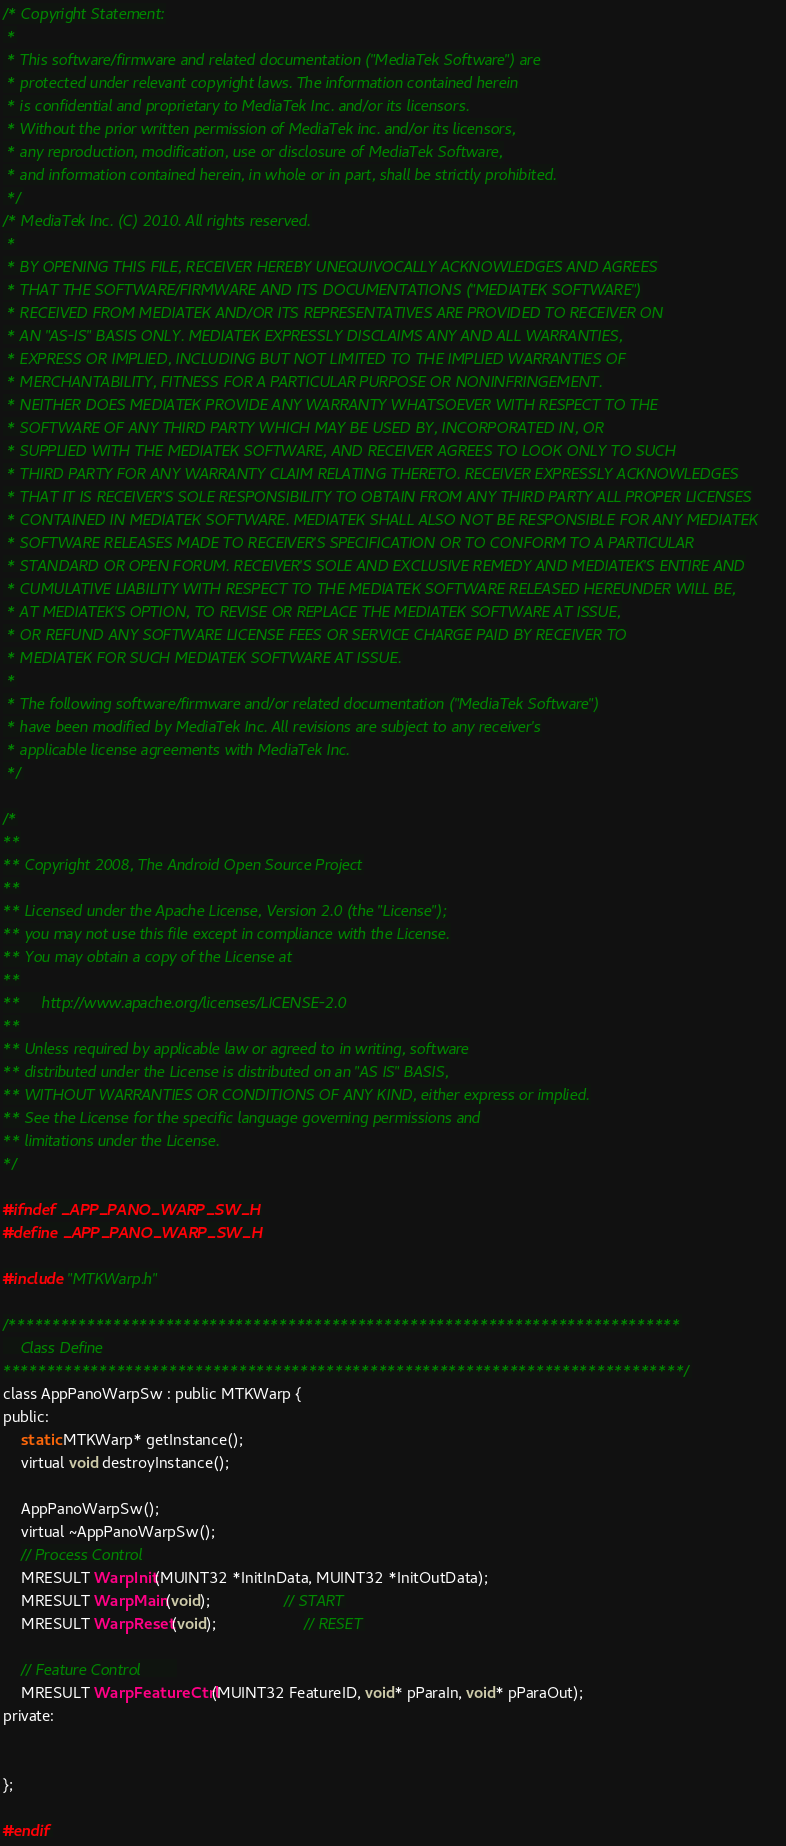Convert code to text. <code><loc_0><loc_0><loc_500><loc_500><_C_>/* Copyright Statement:
 *
 * This software/firmware and related documentation ("MediaTek Software") are
 * protected under relevant copyright laws. The information contained herein
 * is confidential and proprietary to MediaTek Inc. and/or its licensors.
 * Without the prior written permission of MediaTek inc. and/or its licensors,
 * any reproduction, modification, use or disclosure of MediaTek Software,
 * and information contained herein, in whole or in part, shall be strictly prohibited.
 */
/* MediaTek Inc. (C) 2010. All rights reserved.
 *
 * BY OPENING THIS FILE, RECEIVER HEREBY UNEQUIVOCALLY ACKNOWLEDGES AND AGREES
 * THAT THE SOFTWARE/FIRMWARE AND ITS DOCUMENTATIONS ("MEDIATEK SOFTWARE")
 * RECEIVED FROM MEDIATEK AND/OR ITS REPRESENTATIVES ARE PROVIDED TO RECEIVER ON
 * AN "AS-IS" BASIS ONLY. MEDIATEK EXPRESSLY DISCLAIMS ANY AND ALL WARRANTIES,
 * EXPRESS OR IMPLIED, INCLUDING BUT NOT LIMITED TO THE IMPLIED WARRANTIES OF
 * MERCHANTABILITY, FITNESS FOR A PARTICULAR PURPOSE OR NONINFRINGEMENT.
 * NEITHER DOES MEDIATEK PROVIDE ANY WARRANTY WHATSOEVER WITH RESPECT TO THE
 * SOFTWARE OF ANY THIRD PARTY WHICH MAY BE USED BY, INCORPORATED IN, OR
 * SUPPLIED WITH THE MEDIATEK SOFTWARE, AND RECEIVER AGREES TO LOOK ONLY TO SUCH
 * THIRD PARTY FOR ANY WARRANTY CLAIM RELATING THERETO. RECEIVER EXPRESSLY ACKNOWLEDGES
 * THAT IT IS RECEIVER'S SOLE RESPONSIBILITY TO OBTAIN FROM ANY THIRD PARTY ALL PROPER LICENSES
 * CONTAINED IN MEDIATEK SOFTWARE. MEDIATEK SHALL ALSO NOT BE RESPONSIBLE FOR ANY MEDIATEK
 * SOFTWARE RELEASES MADE TO RECEIVER'S SPECIFICATION OR TO CONFORM TO A PARTICULAR
 * STANDARD OR OPEN FORUM. RECEIVER'S SOLE AND EXCLUSIVE REMEDY AND MEDIATEK'S ENTIRE AND
 * CUMULATIVE LIABILITY WITH RESPECT TO THE MEDIATEK SOFTWARE RELEASED HEREUNDER WILL BE,
 * AT MEDIATEK'S OPTION, TO REVISE OR REPLACE THE MEDIATEK SOFTWARE AT ISSUE,
 * OR REFUND ANY SOFTWARE LICENSE FEES OR SERVICE CHARGE PAID BY RECEIVER TO
 * MEDIATEK FOR SUCH MEDIATEK SOFTWARE AT ISSUE.
 *
 * The following software/firmware and/or related documentation ("MediaTek Software")
 * have been modified by MediaTek Inc. All revisions are subject to any receiver's
 * applicable license agreements with MediaTek Inc.
 */

/*
**
** Copyright 2008, The Android Open Source Project
**
** Licensed under the Apache License, Version 2.0 (the "License");
** you may not use this file except in compliance with the License.
** You may obtain a copy of the License at
**
**     http://www.apache.org/licenses/LICENSE-2.0
**
** Unless required by applicable law or agreed to in writing, software
** distributed under the License is distributed on an "AS IS" BASIS,
** WITHOUT WARRANTIES OR CONDITIONS OF ANY KIND, either express or implied.
** See the License for the specific language governing permissions and
** limitations under the License.
*/

#ifndef _APP_PANO_WARP_SW_H
#define _APP_PANO_WARP_SW_H

#include "MTKWarp.h"

/*****************************************************************************
    Class Define
******************************************************************************/
class AppPanoWarpSw : public MTKWarp {
public:    
    static MTKWarp* getInstance();
    virtual void destroyInstance();
    
    AppPanoWarpSw();
    virtual ~AppPanoWarpSw();   
    // Process Control
    MRESULT WarpInit(MUINT32 *InitInData, MUINT32 *InitOutData);
    MRESULT WarpMain(void);                 // START
    MRESULT WarpReset(void);                    // RESET

    // Feature Control        
    MRESULT WarpFeatureCtrl(MUINT32 FeatureID, void* pParaIn, void* pParaOut);  
private:
   

};

#endif

</code> 